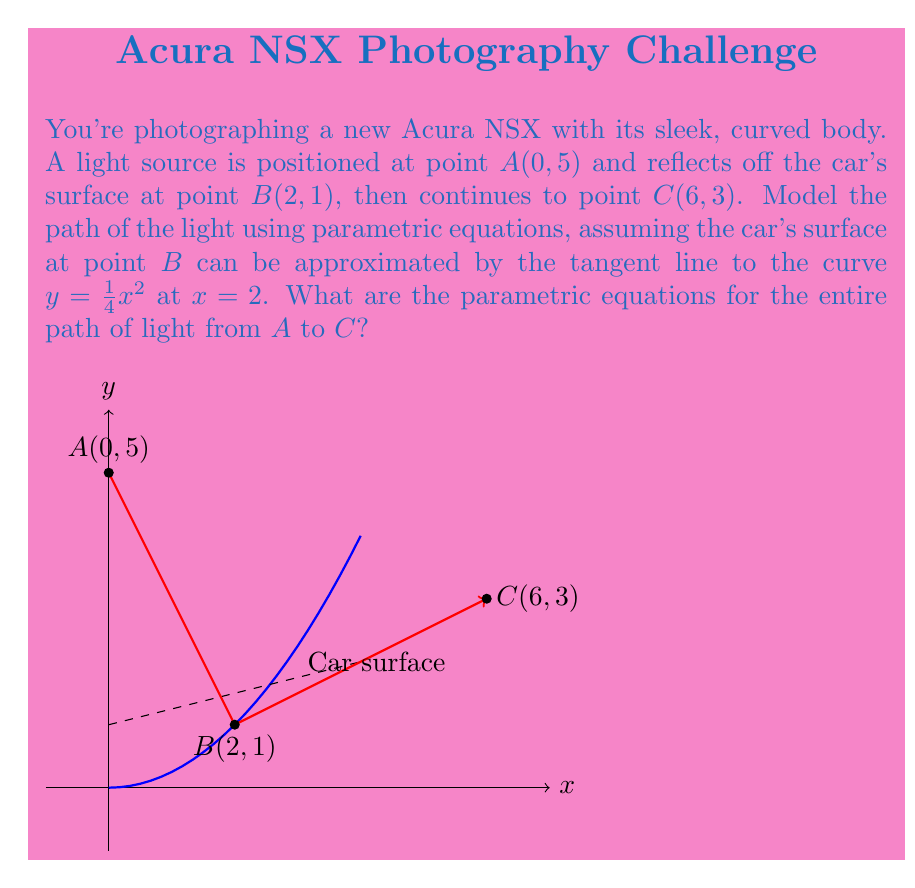What is the answer to this math problem? Let's approach this step-by-step:

1) First, we need to find the equation of the tangent line at point $B(2, 1)$ on the curve $y = \frac{1}{4}x^2$:
   
   The derivative of $y = \frac{1}{4}x^2$ is $y' = \frac{1}{2}x$
   At $x = 2$, $y' = 1$
   
   So the equation of the tangent line is:
   $y - 1 = 1(x - 2)$ or $y = x - 1$

2) Now, let's parameterize the line segment from $A$ to $B$:
   
   $$x_1 = 0 + 2t, y_1 = 5 - 4t, 0 \leq t \leq 1$$

3) For the line segment from $B$ to $C$, we can parameterize it as:
   
   $$x_2 = 2 + 4s, y_2 = 1 + 2s, 0 \leq s \leq 1$$

4) To combine these into a single set of parametric equations, we can use a piecewise function:

   For $0 \leq t \leq 1$:
   $$x = \begin{cases} 
   2t & \text{if } 0 \leq t \leq 1 \\
   2 + 4(t-1) & \text{if } 1 < t \leq 2
   \end{cases}$$

   $$y = \begin{cases}
   5 - 4t & \text{if } 0 \leq t \leq 1 \\
   1 + 2(t-1) & \text{if } 1 < t \leq 2
   \end{cases}$$

These equations describe the entire path of the light from $A$ to $C$, with $t = 0$ corresponding to point $A$, $t = 1$ to point $B$, and $t = 2$ to point $C$.
Answer: $$x = \begin{cases} 
2t & \text{if } 0 \leq t \leq 1 \\
2 + 4(t-1) & \text{if } 1 < t \leq 2
\end{cases}, \quad
y = \begin{cases}
5 - 4t & \text{if } 0 \leq t \leq 1 \\
1 + 2(t-1) & \text{if } 1 < t \leq 2
\end{cases}$$ 